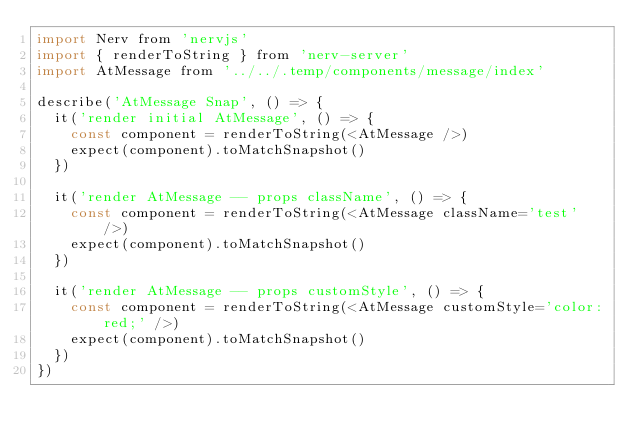Convert code to text. <code><loc_0><loc_0><loc_500><loc_500><_JavaScript_>import Nerv from 'nervjs'
import { renderToString } from 'nerv-server'
import AtMessage from '../../.temp/components/message/index'

describe('AtMessage Snap', () => {
  it('render initial AtMessage', () => {
    const component = renderToString(<AtMessage />)
    expect(component).toMatchSnapshot()
  })

  it('render AtMessage -- props className', () => {
    const component = renderToString(<AtMessage className='test' />)
    expect(component).toMatchSnapshot()
  })

  it('render AtMessage -- props customStyle', () => {
    const component = renderToString(<AtMessage customStyle='color:red;' />)
    expect(component).toMatchSnapshot()
  })
})
</code> 